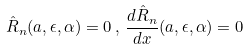<formula> <loc_0><loc_0><loc_500><loc_500>\hat { R } _ { n } ( a , \epsilon , \alpha ) = 0 \, , \, \frac { d \hat { R } _ { n } } { d x } ( a , \epsilon , \alpha ) = 0</formula> 